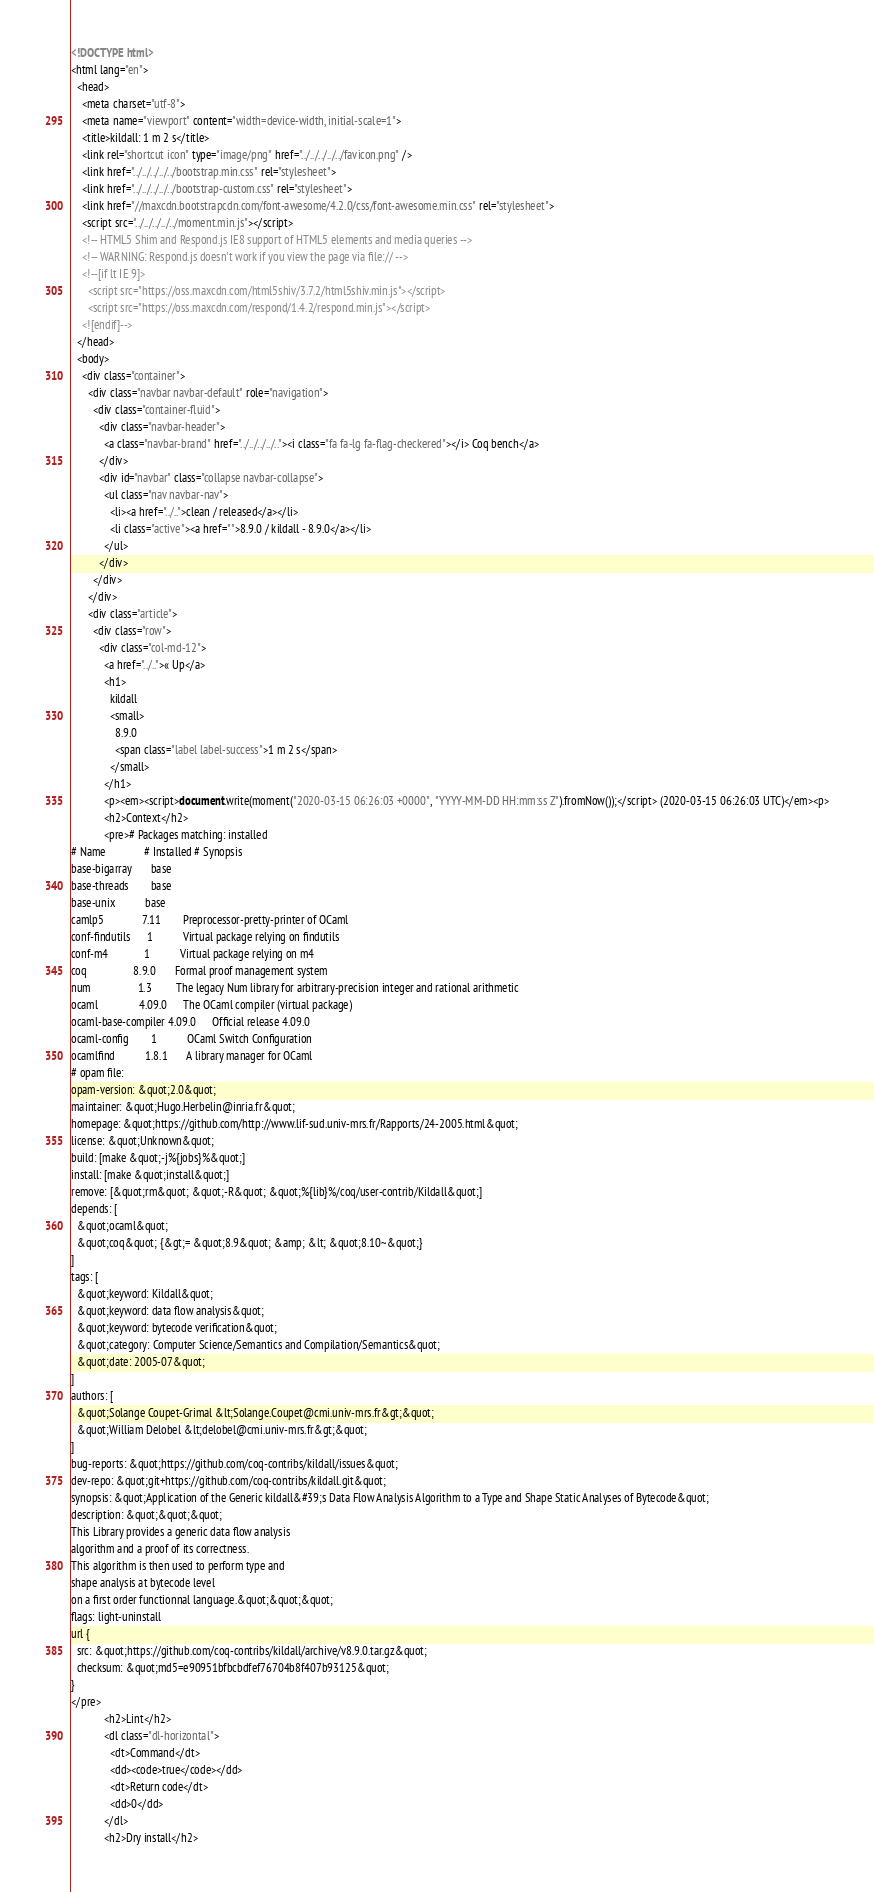Convert code to text. <code><loc_0><loc_0><loc_500><loc_500><_HTML_><!DOCTYPE html>
<html lang="en">
  <head>
    <meta charset="utf-8">
    <meta name="viewport" content="width=device-width, initial-scale=1">
    <title>kildall: 1 m 2 s</title>
    <link rel="shortcut icon" type="image/png" href="../../../../../favicon.png" />
    <link href="../../../../../bootstrap.min.css" rel="stylesheet">
    <link href="../../../../../bootstrap-custom.css" rel="stylesheet">
    <link href="//maxcdn.bootstrapcdn.com/font-awesome/4.2.0/css/font-awesome.min.css" rel="stylesheet">
    <script src="../../../../../moment.min.js"></script>
    <!-- HTML5 Shim and Respond.js IE8 support of HTML5 elements and media queries -->
    <!-- WARNING: Respond.js doesn't work if you view the page via file:// -->
    <!--[if lt IE 9]>
      <script src="https://oss.maxcdn.com/html5shiv/3.7.2/html5shiv.min.js"></script>
      <script src="https://oss.maxcdn.com/respond/1.4.2/respond.min.js"></script>
    <![endif]-->
  </head>
  <body>
    <div class="container">
      <div class="navbar navbar-default" role="navigation">
        <div class="container-fluid">
          <div class="navbar-header">
            <a class="navbar-brand" href="../../../../.."><i class="fa fa-lg fa-flag-checkered"></i> Coq bench</a>
          </div>
          <div id="navbar" class="collapse navbar-collapse">
            <ul class="nav navbar-nav">
              <li><a href="../..">clean / released</a></li>
              <li class="active"><a href="">8.9.0 / kildall - 8.9.0</a></li>
            </ul>
          </div>
        </div>
      </div>
      <div class="article">
        <div class="row">
          <div class="col-md-12">
            <a href="../..">« Up</a>
            <h1>
              kildall
              <small>
                8.9.0
                <span class="label label-success">1 m 2 s</span>
              </small>
            </h1>
            <p><em><script>document.write(moment("2020-03-15 06:26:03 +0000", "YYYY-MM-DD HH:mm:ss Z").fromNow());</script> (2020-03-15 06:26:03 UTC)</em><p>
            <h2>Context</h2>
            <pre># Packages matching: installed
# Name              # Installed # Synopsis
base-bigarray       base
base-threads        base
base-unix           base
camlp5              7.11        Preprocessor-pretty-printer of OCaml
conf-findutils      1           Virtual package relying on findutils
conf-m4             1           Virtual package relying on m4
coq                 8.9.0       Formal proof management system
num                 1.3         The legacy Num library for arbitrary-precision integer and rational arithmetic
ocaml               4.09.0      The OCaml compiler (virtual package)
ocaml-base-compiler 4.09.0      Official release 4.09.0
ocaml-config        1           OCaml Switch Configuration
ocamlfind           1.8.1       A library manager for OCaml
# opam file:
opam-version: &quot;2.0&quot;
maintainer: &quot;Hugo.Herbelin@inria.fr&quot;
homepage: &quot;https://github.com/http://www.lif-sud.univ-mrs.fr/Rapports/24-2005.html&quot;
license: &quot;Unknown&quot;
build: [make &quot;-j%{jobs}%&quot;]
install: [make &quot;install&quot;]
remove: [&quot;rm&quot; &quot;-R&quot; &quot;%{lib}%/coq/user-contrib/Kildall&quot;]
depends: [
  &quot;ocaml&quot;
  &quot;coq&quot; {&gt;= &quot;8.9&quot; &amp; &lt; &quot;8.10~&quot;}
]
tags: [
  &quot;keyword: Kildall&quot;
  &quot;keyword: data flow analysis&quot;
  &quot;keyword: bytecode verification&quot;
  &quot;category: Computer Science/Semantics and Compilation/Semantics&quot;
  &quot;date: 2005-07&quot;
]
authors: [
  &quot;Solange Coupet-Grimal &lt;Solange.Coupet@cmi.univ-mrs.fr&gt;&quot;
  &quot;William Delobel &lt;delobel@cmi.univ-mrs.fr&gt;&quot;
]
bug-reports: &quot;https://github.com/coq-contribs/kildall/issues&quot;
dev-repo: &quot;git+https://github.com/coq-contribs/kildall.git&quot;
synopsis: &quot;Application of the Generic kildall&#39;s Data Flow Analysis Algorithm to a Type and Shape Static Analyses of Bytecode&quot;
description: &quot;&quot;&quot;
This Library provides a generic data flow analysis
algorithm and a proof of its correctness.
This algorithm is then used to perform type and
shape analysis at bytecode level
on a first order functionnal language.&quot;&quot;&quot;
flags: light-uninstall
url {
  src: &quot;https://github.com/coq-contribs/kildall/archive/v8.9.0.tar.gz&quot;
  checksum: &quot;md5=e90951bfbcbdfef76704b8f407b93125&quot;
}
</pre>
            <h2>Lint</h2>
            <dl class="dl-horizontal">
              <dt>Command</dt>
              <dd><code>true</code></dd>
              <dt>Return code</dt>
              <dd>0</dd>
            </dl>
            <h2>Dry install</h2></code> 